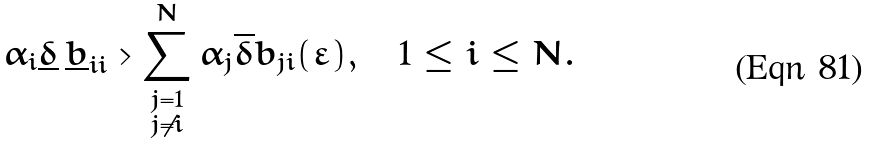Convert formula to latex. <formula><loc_0><loc_0><loc_500><loc_500>\alpha _ { i } \underline { \delta } \, \underline { b } _ { i i } > \sum _ { \substack { j = 1 \\ j \neq i } } ^ { N } \alpha _ { j } \overline { \delta } \bar { b } _ { j i } ( \varepsilon ) , \quad 1 \leq i \leq N .</formula> 